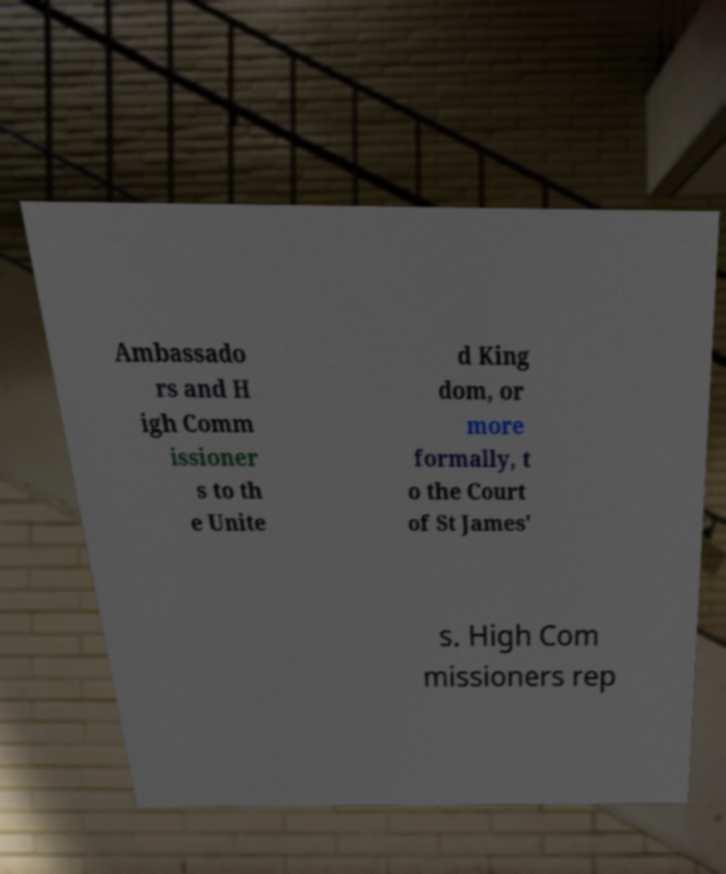Can you read and provide the text displayed in the image?This photo seems to have some interesting text. Can you extract and type it out for me? Ambassado rs and H igh Comm issioner s to th e Unite d King dom, or more formally, t o the Court of St James' s. High Com missioners rep 